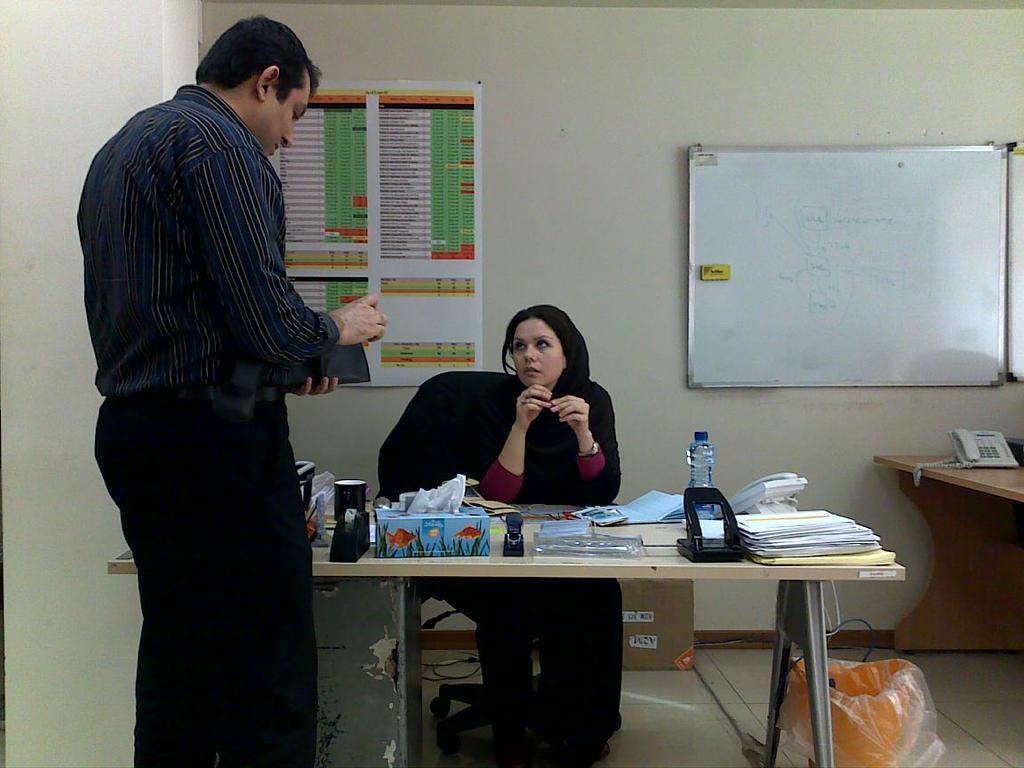Can you describe this image briefly? In this picture we can see a lady sitting on the chair in front of table on which there are some things and a man standing in front of them. 